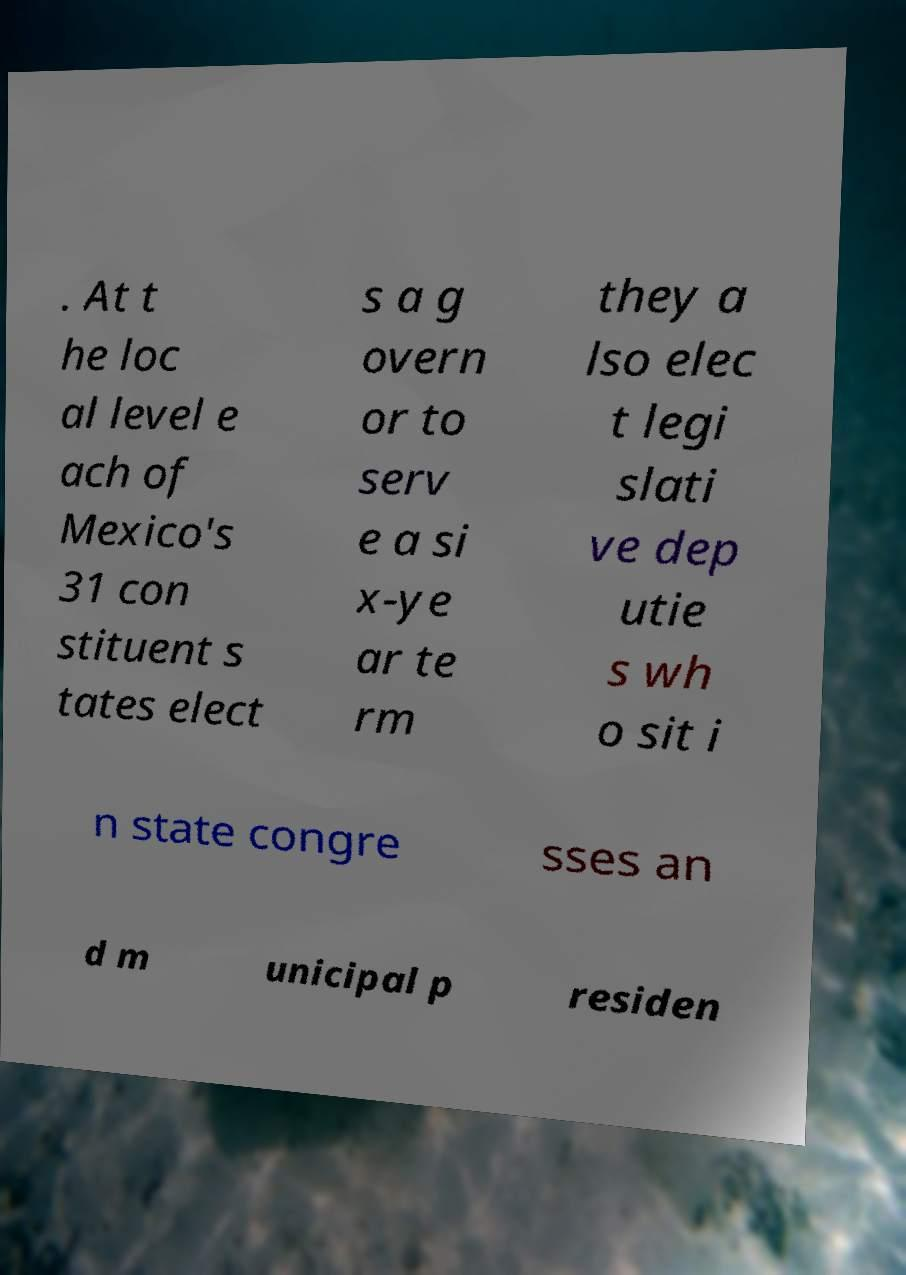There's text embedded in this image that I need extracted. Can you transcribe it verbatim? . At t he loc al level e ach of Mexico's 31 con stituent s tates elect s a g overn or to serv e a si x-ye ar te rm they a lso elec t legi slati ve dep utie s wh o sit i n state congre sses an d m unicipal p residen 